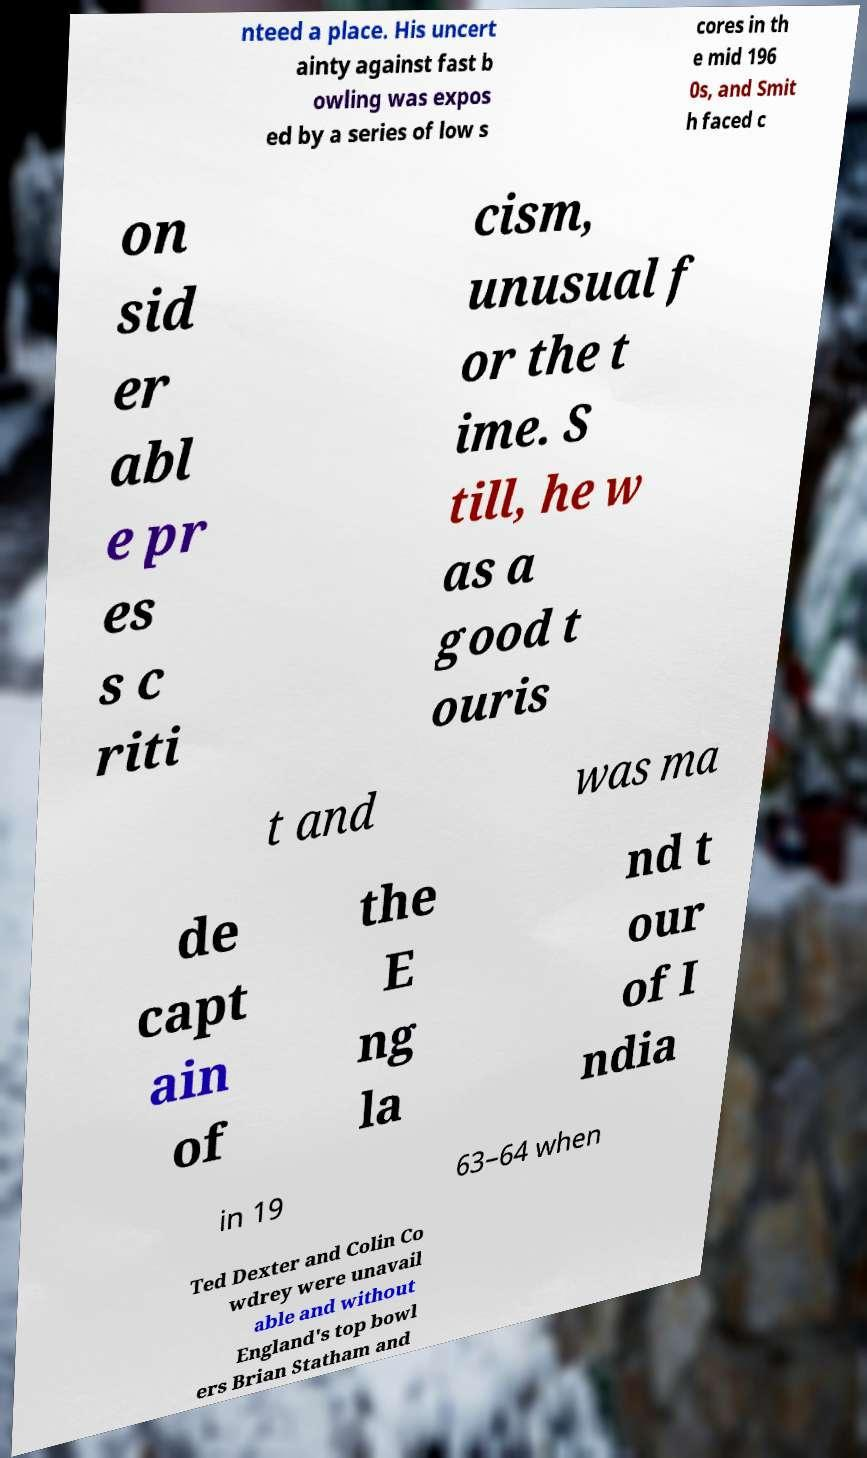What messages or text are displayed in this image? I need them in a readable, typed format. nteed a place. His uncert ainty against fast b owling was expos ed by a series of low s cores in th e mid 196 0s, and Smit h faced c on sid er abl e pr es s c riti cism, unusual f or the t ime. S till, he w as a good t ouris t and was ma de capt ain of the E ng la nd t our of I ndia in 19 63–64 when Ted Dexter and Colin Co wdrey were unavail able and without England's top bowl ers Brian Statham and 